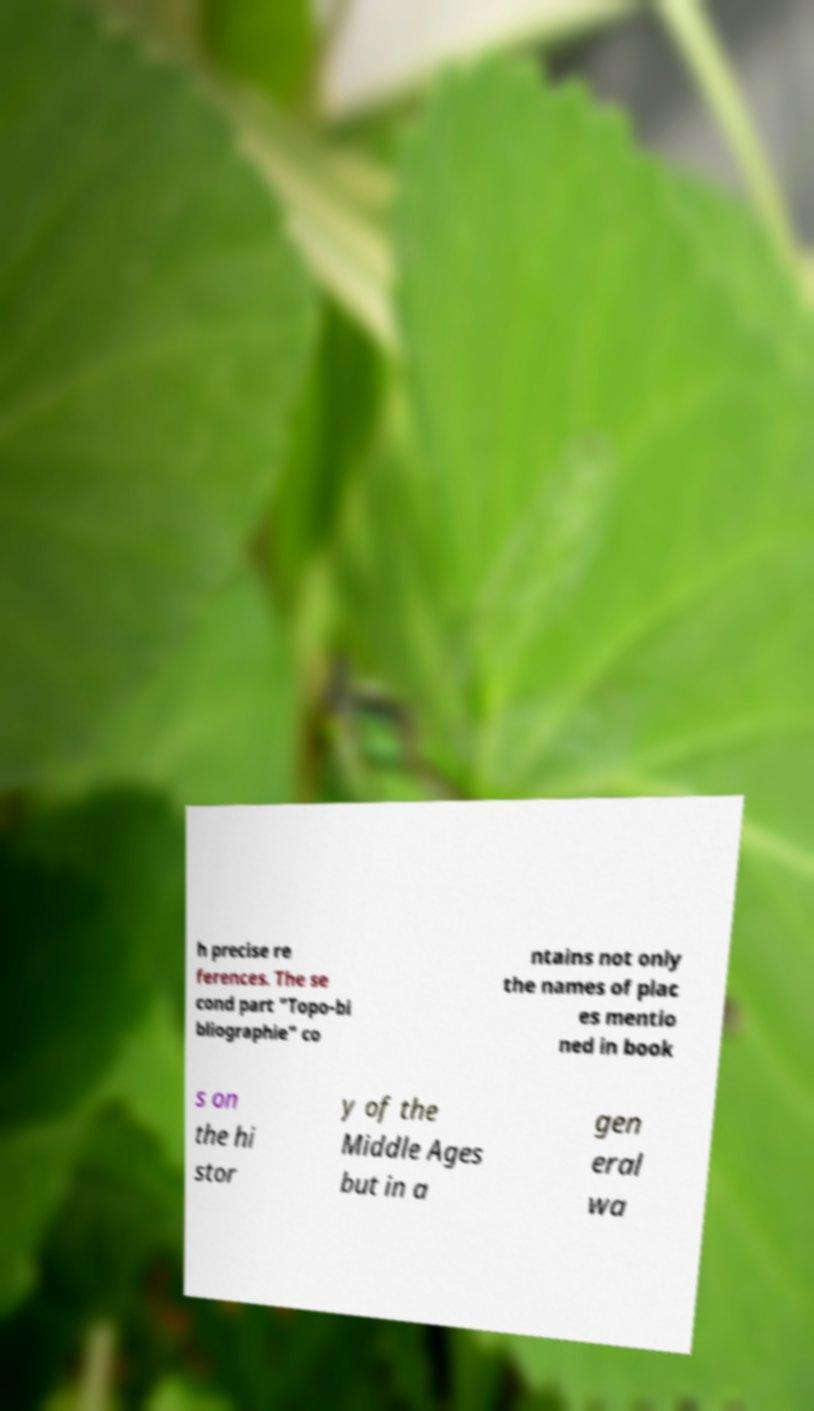For documentation purposes, I need the text within this image transcribed. Could you provide that? h precise re ferences. The se cond part "Topo-bi bliographie" co ntains not only the names of plac es mentio ned in book s on the hi stor y of the Middle Ages but in a gen eral wa 